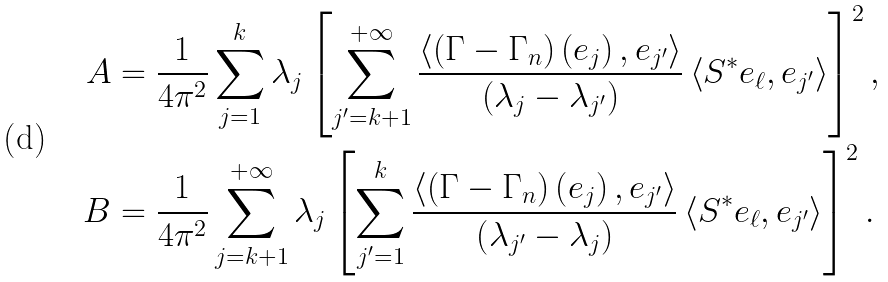<formula> <loc_0><loc_0><loc_500><loc_500>A & = \frac { 1 } { 4 \pi ^ { 2 } } \sum _ { j = 1 } ^ { k } \lambda _ { j } \left [ \sum _ { j ^ { \prime } = k + 1 } ^ { + \infty } \frac { \left \langle \left ( \Gamma - \Gamma _ { n } \right ) \left ( e _ { j } \right ) , e _ { j ^ { \prime } } \right \rangle } { \left ( \lambda _ { j } - \lambda _ { j ^ { \prime } } \right ) } \left \langle S ^ { \ast } e _ { \ell } , e _ { j ^ { \prime } } \right \rangle \right ] ^ { 2 } , \\ B & = \frac { 1 } { 4 \pi ^ { 2 } } \sum _ { j = k + 1 } ^ { + \infty } \lambda _ { j } \left [ \sum _ { j ^ { \prime } = 1 } ^ { k } \frac { \left \langle \left ( \Gamma - \Gamma _ { n } \right ) \left ( e _ { j } \right ) , e _ { j ^ { \prime } } \right \rangle } { \left ( \lambda _ { j ^ { \prime } } - \lambda _ { j } \right ) } \left \langle S ^ { \ast } e _ { \ell } , e _ { j ^ { \prime } } \right \rangle \right ] ^ { 2 } .</formula> 